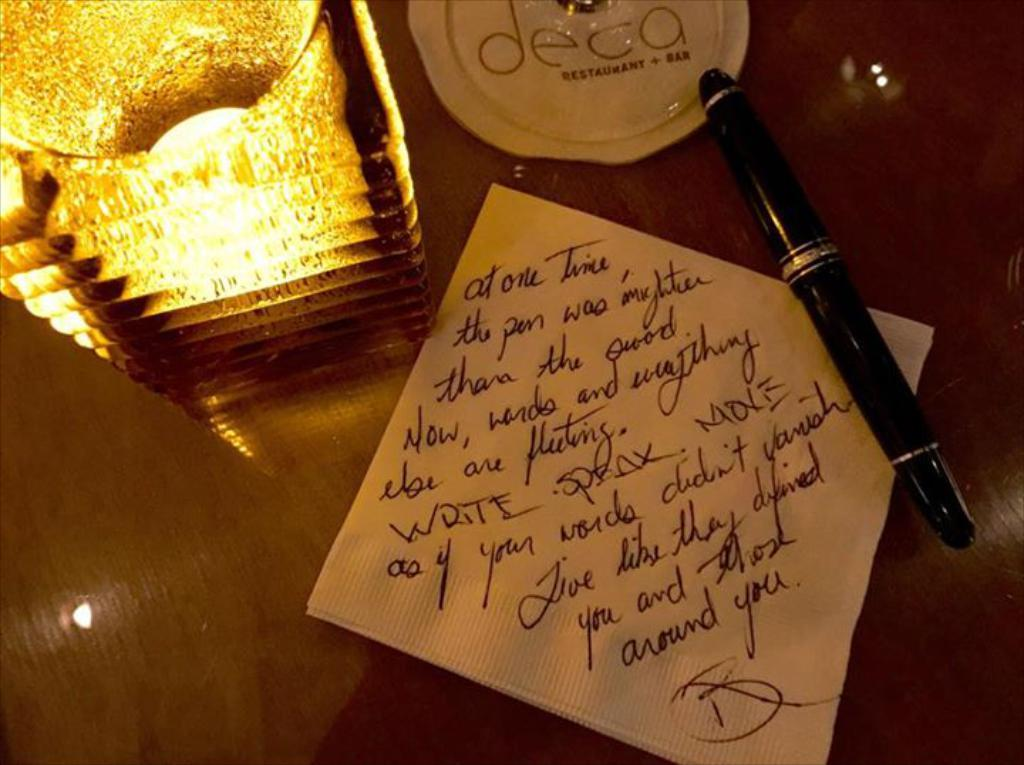What object can be seen providing light in the image? There is a lamp in the image. What is the lamp, paper, and pen placed on in the image? They are placed on a table. What might be used for writing in the image? There is a pen in the image. What is the paper used for in the image? The paper might be used for writing or drawing. How many cars are parked next to the table in the image? There are no cars present in the image. What type of bat is flying near the lamp in the image? There are no bats present in the image. 